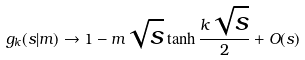Convert formula to latex. <formula><loc_0><loc_0><loc_500><loc_500>g _ { k } ( s | m ) \to 1 - m \sqrt { s } \tanh \frac { k \sqrt { s } } { 2 } + O ( s )</formula> 